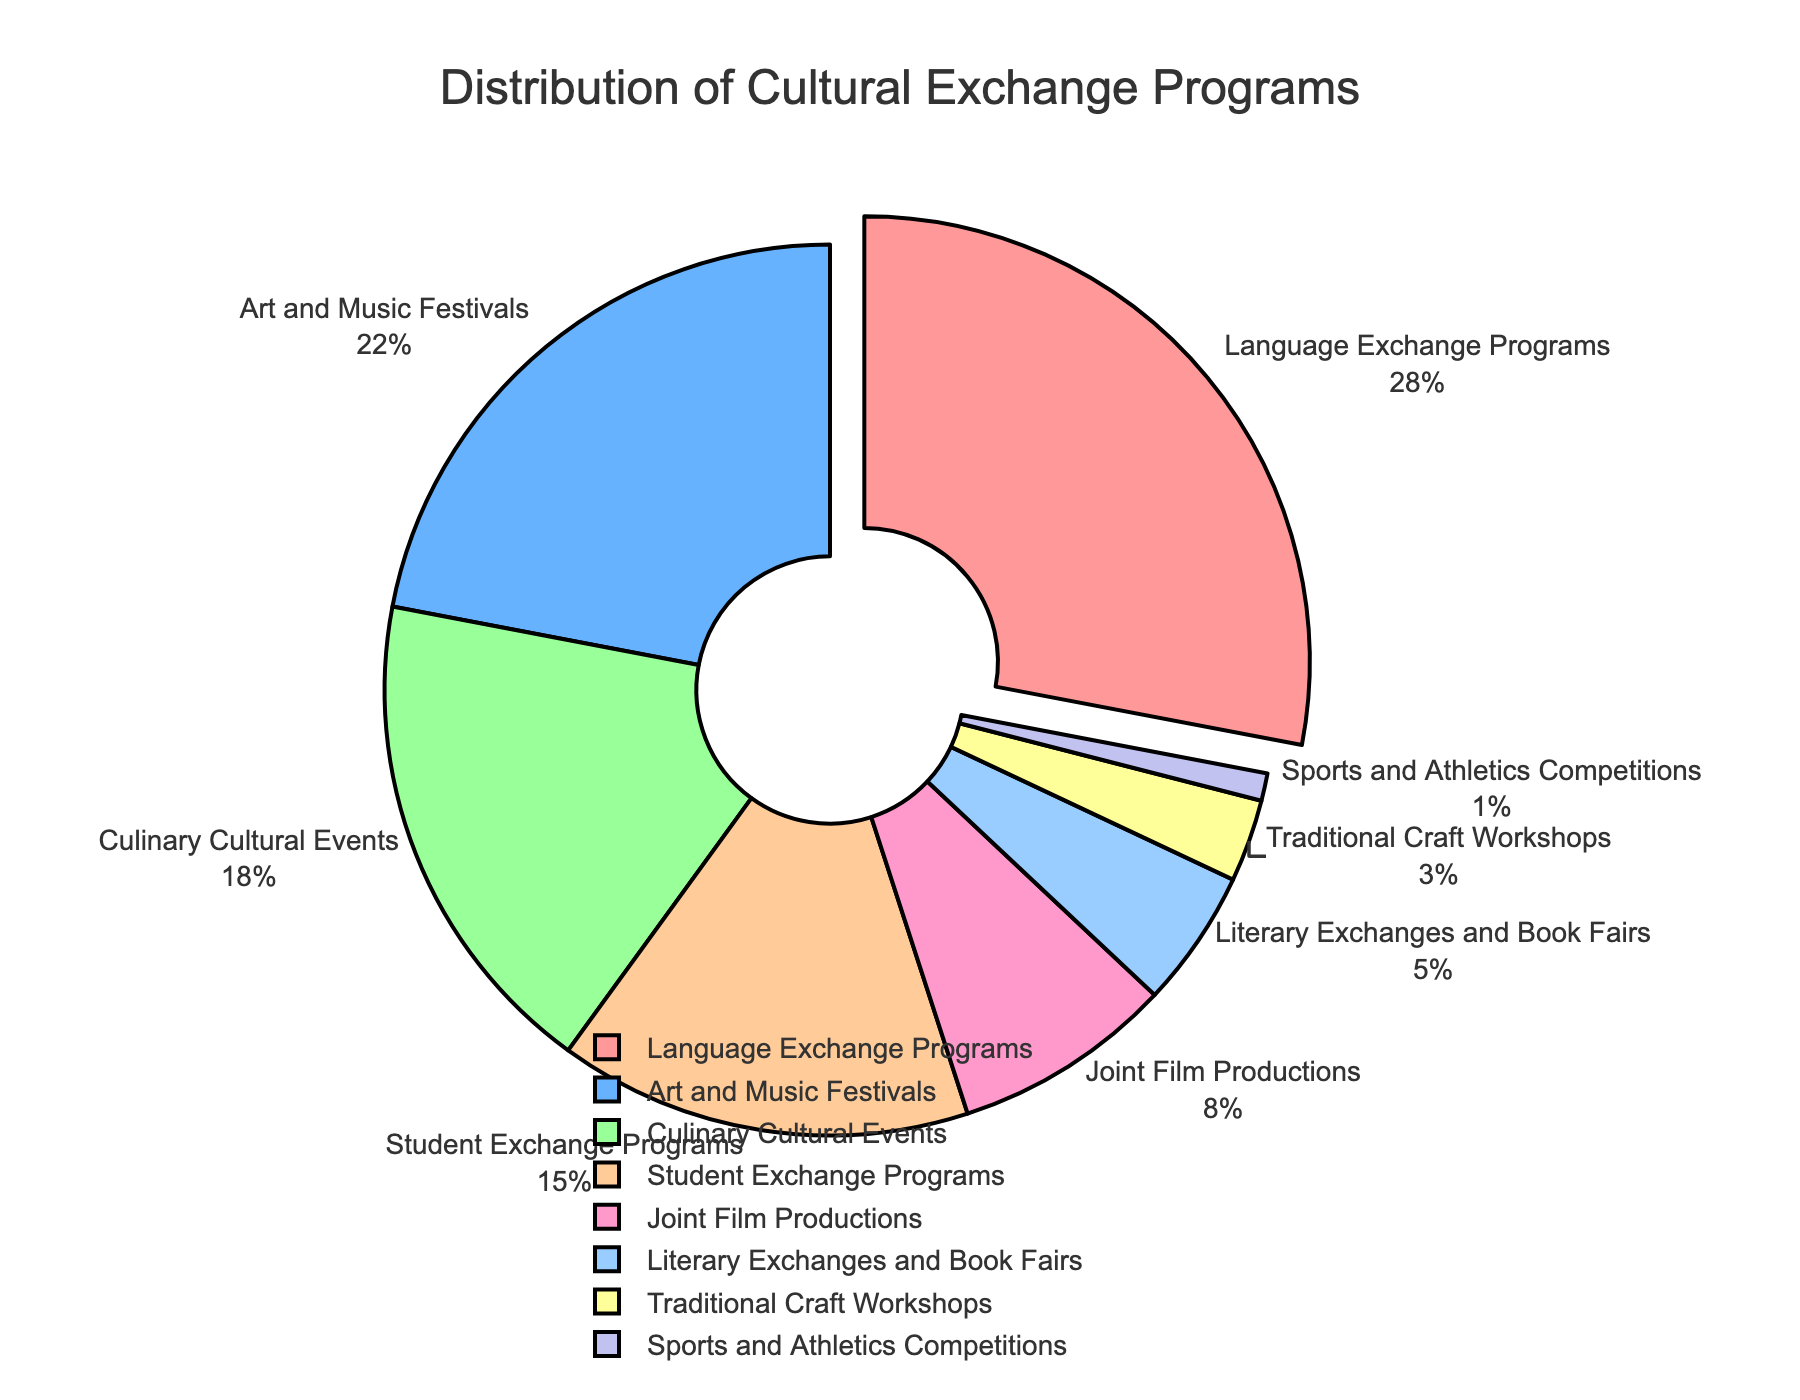Which type of cultural exchange program has the highest percentage? The figure highlights 'Language Exchange Programs' by pulling the slice out, indicating it has the highest percentage. Specifically, it shows 28%.
Answer: Language Exchange Programs, 28% How does the percentage of 'Art and Music Festivals' compare to 'Culinary Cultural Events'? The pie chart shows that 'Art and Music Festivals' have a percentage of 22%, while 'Culinary Cultural Events' have a percentage of 18%. Therefore, 'Art and Music Festivals' have a higher percentage.
Answer: Art and Music Festivals, 22% > Culinary Cultural Events, 18% What is the total percentage of 'Student Exchange Programs' and 'Joint Film Productions'? According to the pie chart, 'Student Exchange Programs' account for 15% and 'Joint Film Productions' for 8%. Adding these together gives 15% + 8% = 23%.
Answer: 23% Which cultural exchange program has the lowest percentage? By examining the pie chart, it is clear that 'Sports and Athletics Competitions' has the smallest slice, representing 1%.
Answer: Sports and Athletics Competitions, 1% What is the combined percentage of 'Literary Exchanges and Book Fairs' and 'Traditional Craft Workshops'? The pie chart shows that 'Literary Exchanges and Book Fairs' account for 5% and 'Traditional Craft Workshops' for 3%. Summing these gives 5% + 3% = 8%.
Answer: 8% How does 'Traditional Craft Workshops' compare to 'Art and Music Festivals' in terms of percentage? 'Traditional Craft Workshops' account for 3% while 'Art and Music Festivals' account for 22%. Therefore, 'Art and Music Festivals' have a significantly higher percentage.
Answer: Art and Music Festivals, 22% > Traditional Craft Workshops, 3% What is the difference in percentage between 'Culinary Cultural Events' and 'Student Exchange Programs'? According to the figure, 'Culinary Cultural Events' are at 18% while 'Student Exchange Programs' are at 15%. The difference is 18% - 15% = 3%.
Answer: 3% Which program occupies the second-largest portion of the pie chart? The second-largest portion of the pie chart belongs to 'Art and Music Festivals,' which account for 22%.
Answer: Art and Music Festivals, 22% What is the total percentage of 'Language Exchange Programs,' 'Art and Music Festivals,' and 'Culinary Cultural Events'? Summing the percentages of 'Language Exchange Programs' (28%), 'Art and Music Festivals' (22%), and 'Culinary Cultural Events' (18%) gives 28% + 22% + 18% = 68%.
Answer: 68% What is the difference in percentage between the largest and smallest types of cultural exchange programs? The largest percentage is 'Language Exchange Programs' at 28%, and the smallest is 'Sports and Athletics Competitions' at 1%. The difference is 28% - 1% = 27%.
Answer: 27% 